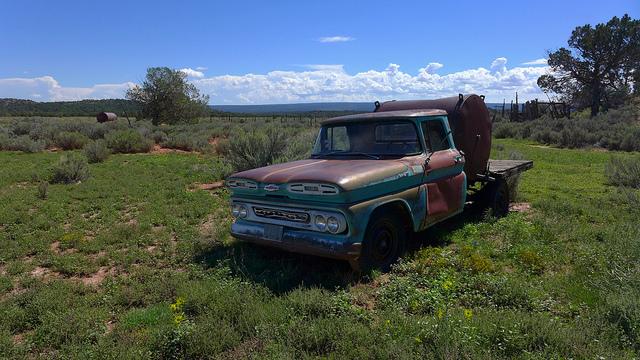Is the truck on a highway?
Write a very short answer. No. What color is the truck?
Give a very brief answer. Green. What color are the vehicles?
Answer briefly. Green. Is this a new truck?
Concise answer only. No. Has the older truck been well maintained mechanically?
Quick response, please. No. What seems to have happened to the vehicle before it was abandoned?
Write a very short answer. Broke down. What color is the drivers side door?
Quick response, please. Red. How many vehicles is there?
Short answer required. 1. 